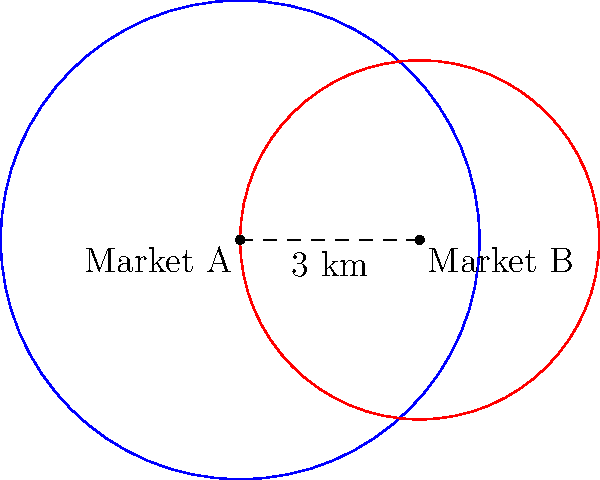As a marketing executive, you're analyzing the overlap between two circular market segments. Market A has a radius of 4 km centered at (0,0), while Market B has a radius of 3 km centered at (3,0). Calculate the area of overlap between these two market segments to determine the region where both marketing campaigns intersect. Round your answer to the nearest square kilometer. To find the area of overlap between two circles, we'll use the following steps:

1) First, calculate the distance $d$ between the centers:
   $d = 3$ km (given in the diagram)

2) Check if the circles intersect:
   $r_1 + r_2 > d > |r_1 - r_2|$
   $7 > 3 > 1$, so they do intersect.

3) Calculate the angle $\theta$ for each circle:
   $\theta_1 = 2 \arccos(\frac{d^2 + r_1^2 - r_2^2}{2dr_1})$
   $\theta_1 = 2 \arccos(\frac{3^2 + 4^2 - 3^2}{2 \cdot 3 \cdot 4}) = 2.498$ radians

   $\theta_2 = 2 \arccos(\frac{d^2 + r_2^2 - r_1^2}{2dr_2})$
   $\theta_2 = 2 \arccos(\frac{3^2 + 3^2 - 4^2}{2 \cdot 3 \cdot 3}) = 3.284$ radians

4) Calculate the area of each sector:
   $A_1 = \frac{1}{2} r_1^2 \theta_1 = \frac{1}{2} \cdot 4^2 \cdot 2.498 = 19.984$ km²
   $A_2 = \frac{1}{2} r_2^2 \theta_2 = \frac{1}{2} \cdot 3^2 \cdot 3.284 = 14.778$ km²

5) Calculate the area of each triangle:
   $T_1 = \frac{1}{2} r_1^2 \sin(\theta_1) = \frac{1}{2} \cdot 4^2 \cdot \sin(2.498) = 7.775$ km²
   $T_2 = \frac{1}{2} r_2^2 \sin(\theta_2) = \frac{1}{2} \cdot 3^2 \cdot \sin(3.284) = 4.378$ km²

6) The area of overlap is:
   $A_{overlap} = A_1 + A_2 - T_1 - T_2$
   $A_{overlap} = 19.984 + 14.778 - 7.775 - 4.378 = 22.609$ km²

7) Rounding to the nearest square kilometer:
   $A_{overlap} \approx 23$ km²
Answer: 23 km² 